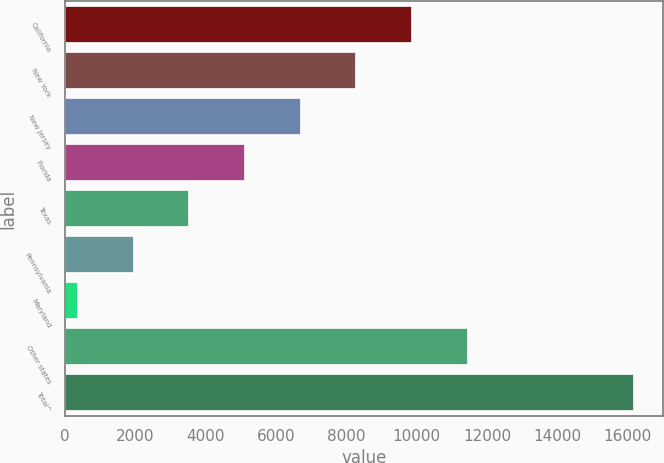Convert chart to OTSL. <chart><loc_0><loc_0><loc_500><loc_500><bar_chart><fcel>California<fcel>New York<fcel>New Jersey<fcel>Florida<fcel>Texas<fcel>Pennsylvania<fcel>Maryland<fcel>Other states<fcel>Total^<nl><fcel>9868.6<fcel>8287<fcel>6705.4<fcel>5123.8<fcel>3542.2<fcel>1960.6<fcel>379<fcel>11450.2<fcel>16195<nl></chart> 